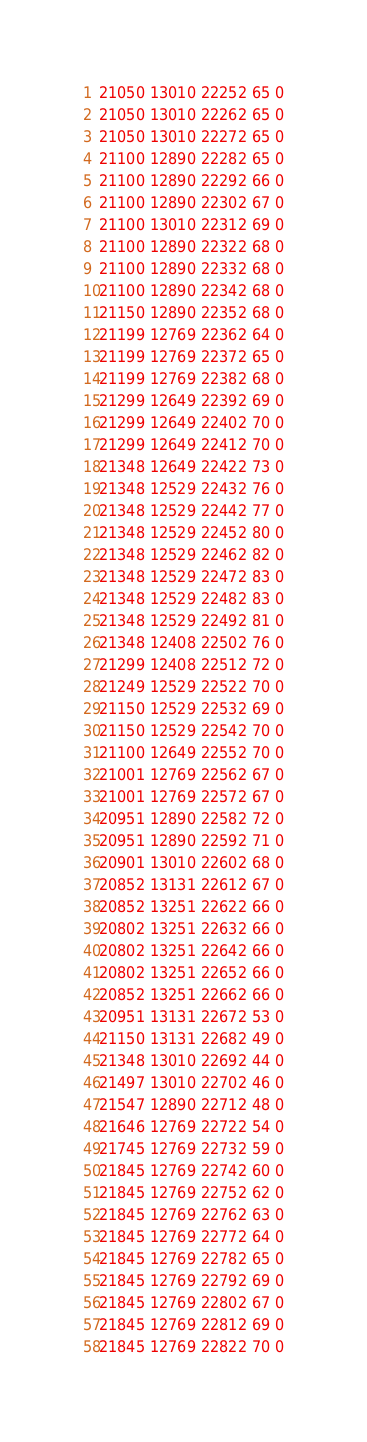Convert code to text. <code><loc_0><loc_0><loc_500><loc_500><_SML_>21050 13010 22252 65 0
21050 13010 22262 65 0
21050 13010 22272 65 0
21100 12890 22282 65 0
21100 12890 22292 66 0
21100 12890 22302 67 0
21100 13010 22312 69 0
21100 12890 22322 68 0
21100 12890 22332 68 0
21100 12890 22342 68 0
21150 12890 22352 68 0
21199 12769 22362 64 0
21199 12769 22372 65 0
21199 12769 22382 68 0
21299 12649 22392 69 0
21299 12649 22402 70 0
21299 12649 22412 70 0
21348 12649 22422 73 0
21348 12529 22432 76 0
21348 12529 22442 77 0
21348 12529 22452 80 0
21348 12529 22462 82 0
21348 12529 22472 83 0
21348 12529 22482 83 0
21348 12529 22492 81 0
21348 12408 22502 76 0
21299 12408 22512 72 0
21249 12529 22522 70 0
21150 12529 22532 69 0
21150 12529 22542 70 0
21100 12649 22552 70 0
21001 12769 22562 67 0
21001 12769 22572 67 0
20951 12890 22582 72 0
20951 12890 22592 71 0
20901 13010 22602 68 0
20852 13131 22612 67 0
20852 13251 22622 66 0
20802 13251 22632 66 0
20802 13251 22642 66 0
20802 13251 22652 66 0
20852 13251 22662 66 0
20951 13131 22672 53 0
21150 13131 22682 49 0
21348 13010 22692 44 0
21497 13010 22702 46 0
21547 12890 22712 48 0
21646 12769 22722 54 0
21745 12769 22732 59 0
21845 12769 22742 60 0
21845 12769 22752 62 0
21845 12769 22762 63 0
21845 12769 22772 64 0
21845 12769 22782 65 0
21845 12769 22792 69 0
21845 12769 22802 67 0
21845 12769 22812 69 0
21845 12769 22822 70 0</code> 